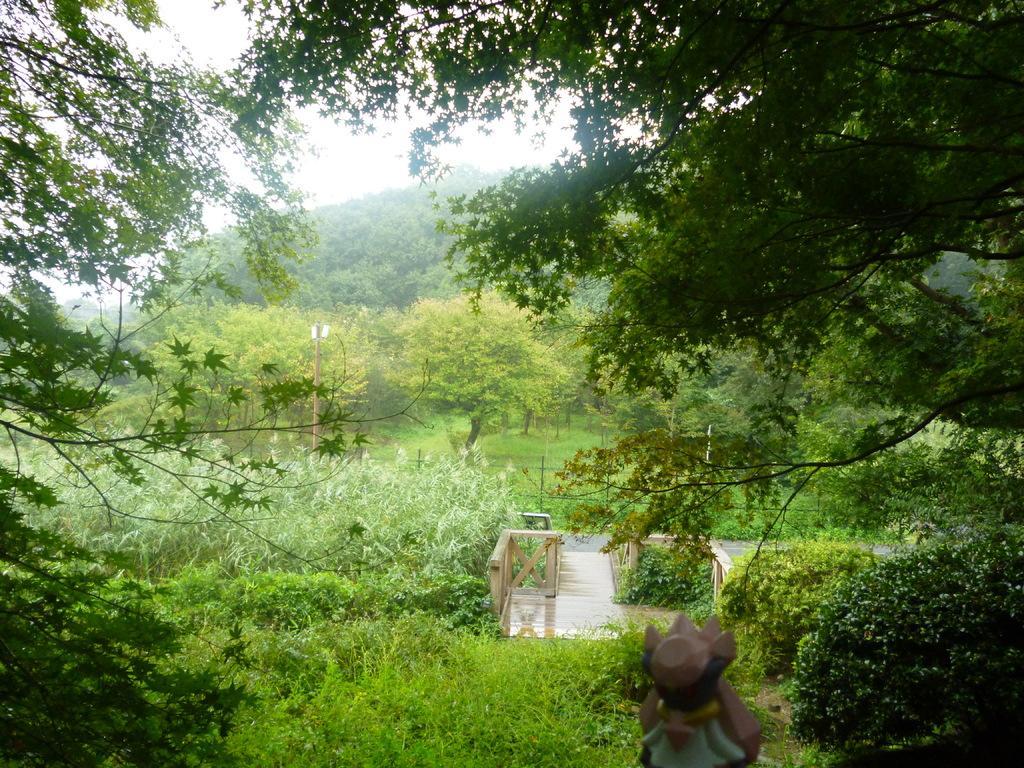In one or two sentences, can you explain what this image depicts? There are trees and plants. Also there are wooden railing with wooden path. In the background there is sky. 